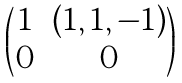<formula> <loc_0><loc_0><loc_500><loc_500>\begin{pmatrix} 1 & ( 1 , 1 , - 1 ) \\ 0 & 0 \end{pmatrix}</formula> 